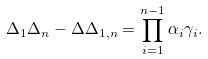Convert formula to latex. <formula><loc_0><loc_0><loc_500><loc_500>\Delta _ { 1 } \Delta _ { n } - \Delta \Delta _ { 1 , n } = \prod _ { i = 1 } ^ { n - 1 } \alpha _ { i } \gamma _ { i } .</formula> 